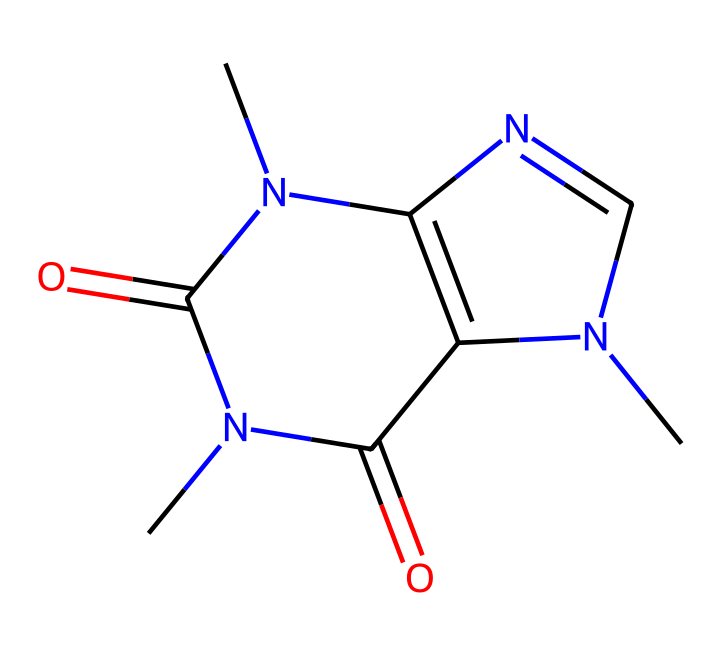What is the molecular formula of caffeine? To find the molecular formula, count the number of each type of atom in the SMILES representation. The molecule consists of carbon (C), hydrogen (H), nitrogen (N), and oxygen (O). The counts are 8 C, 10 H, 4 N, and 2 O. Thus, the molecular formula is C8H10N4O2.
Answer: C8H10N4O2 How many nitrogen atoms are present in caffeine? By examining the SMILES representation, we can see that there are four 'N' symbols, indicating the presence of four nitrogen atoms in the structure.
Answer: 4 What type of chemical compound is caffeine classified as? Caffeine is primarily classified as an alkaloid due to the presence of nitrogen atoms and its stimulant properties. Alkaloids are naturally occurring compounds that often have pharmacological effects.
Answer: alkaloid What is the total number of rings in the caffeine structure? By analyzing the SMILES representation, we can identify that there are two rings present in the structure: one ring formed by the connected nitrogen and carbon atoms, and another interconnected ring as part of its bicyclic structure.
Answer: 2 Which atoms are involved in the hydrogen bonding within caffeine? The structure contains nitrogen and oxygen atoms that typically facilitate hydrogen bonding. In caffeine, the nitrogen atoms can participate in hydrogen bonding due to their electronegativity.
Answer: nitrogen and oxygen What are the functional groups present in caffeine? The SMILES representation reveals the presence of an amine group (due to nitrogen) and carbonyl groups (due to oxygen double-bonded to carbon). These functional groups are influential in its medicinal properties.
Answer: amine and carbonyl 